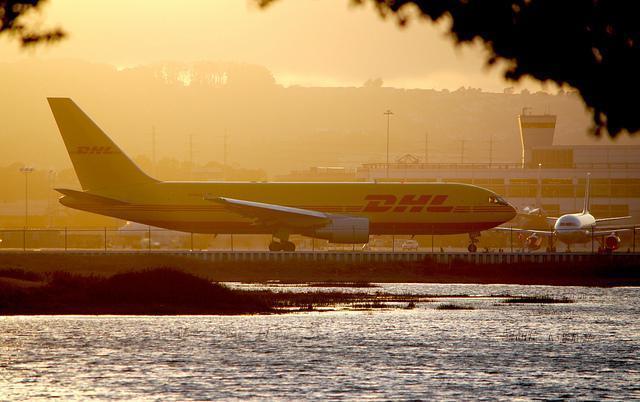How many airplanes are visible?
Give a very brief answer. 2. 